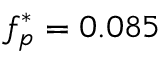<formula> <loc_0><loc_0><loc_500><loc_500>f _ { p } ^ { * } = 0 . 0 8 5</formula> 